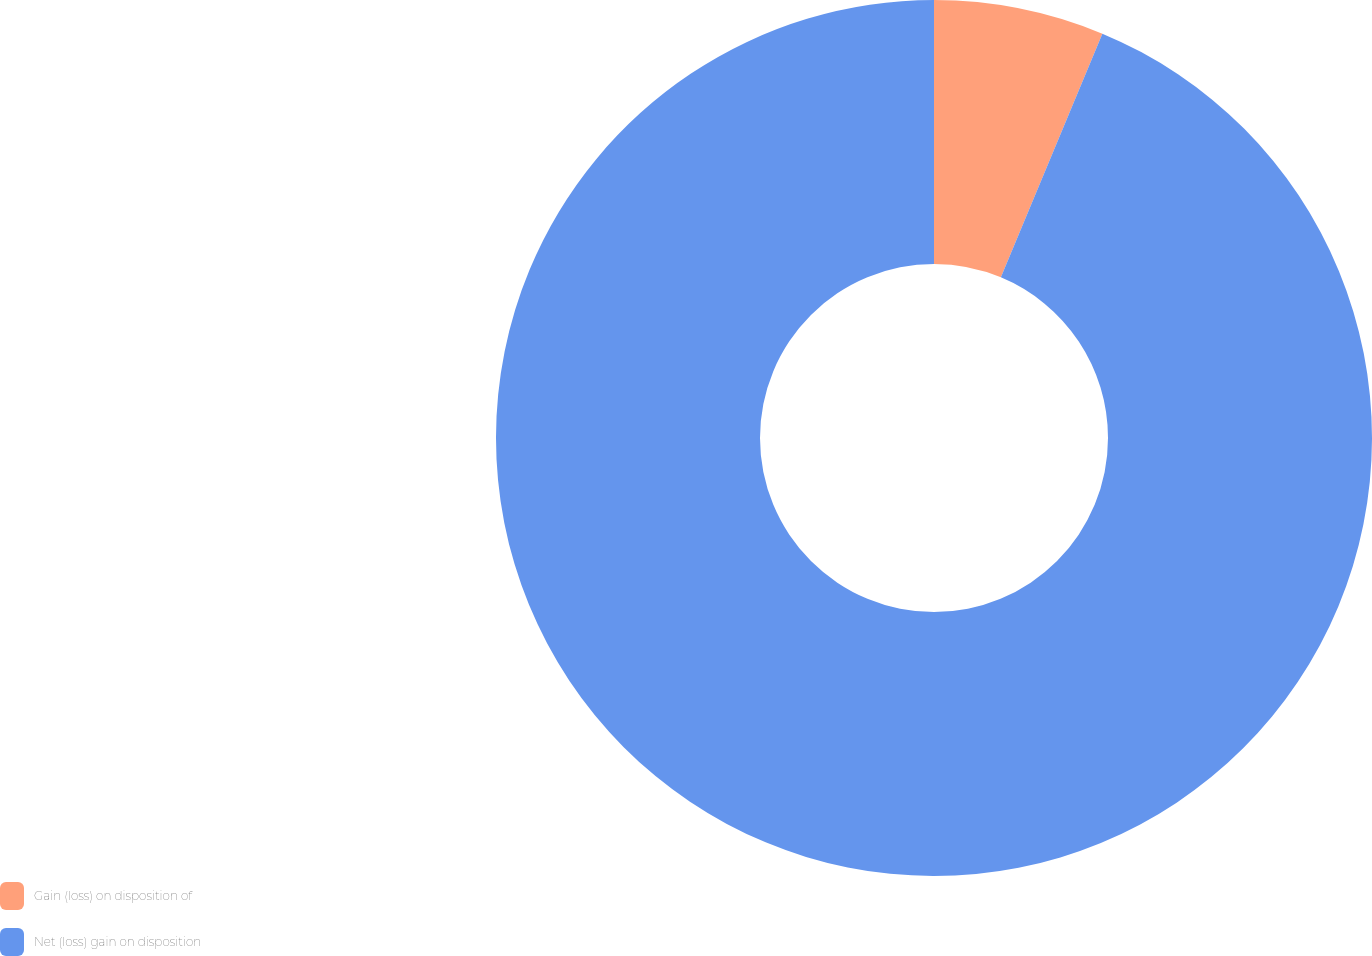Convert chart to OTSL. <chart><loc_0><loc_0><loc_500><loc_500><pie_chart><fcel>Gain (loss) on disposition of<fcel>Net (loss) gain on disposition<nl><fcel>6.28%<fcel>93.72%<nl></chart> 